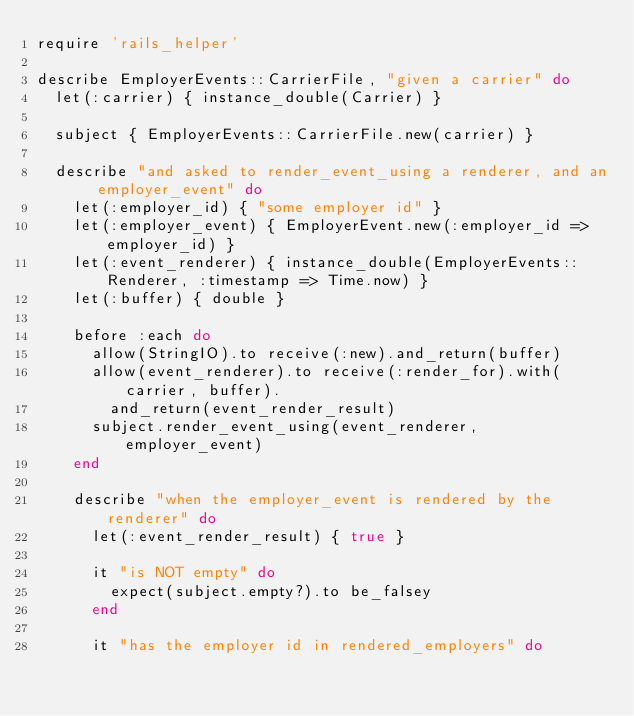<code> <loc_0><loc_0><loc_500><loc_500><_Ruby_>require 'rails_helper'

describe EmployerEvents::CarrierFile, "given a carrier" do
  let(:carrier) { instance_double(Carrier) }
  
  subject { EmployerEvents::CarrierFile.new(carrier) }

  describe "and asked to render_event_using a renderer, and an employer_event" do
    let(:employer_id) { "some employer id" }
    let(:employer_event) { EmployerEvent.new(:employer_id => employer_id) }
    let(:event_renderer) { instance_double(EmployerEvents::Renderer, :timestamp => Time.now) }
    let(:buffer) { double }

    before :each do
      allow(StringIO).to receive(:new).and_return(buffer)
      allow(event_renderer).to receive(:render_for).with(carrier, buffer).
        and_return(event_render_result)
      subject.render_event_using(event_renderer, employer_event)
    end

    describe "when the employer_event is rendered by the renderer" do
      let(:event_render_result) { true }

      it "is NOT empty" do
        expect(subject.empty?).to be_falsey
      end

      it "has the employer id in rendered_employers" do</code> 